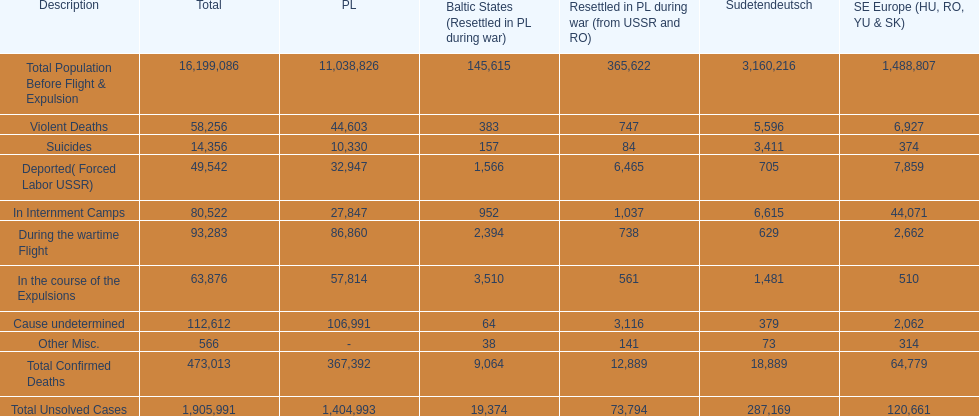Which country had the larger death tole? Poland. 